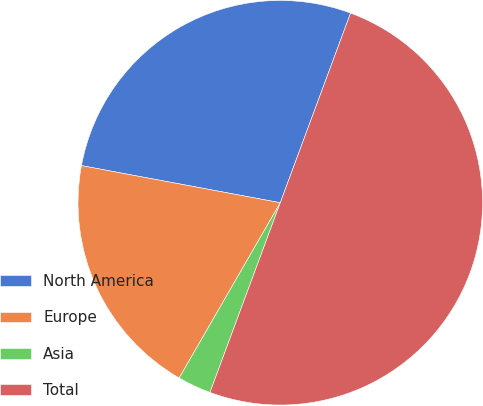Convert chart. <chart><loc_0><loc_0><loc_500><loc_500><pie_chart><fcel>North America<fcel>Europe<fcel>Asia<fcel>Total<nl><fcel>27.71%<fcel>19.61%<fcel>2.68%<fcel>50.0%<nl></chart> 